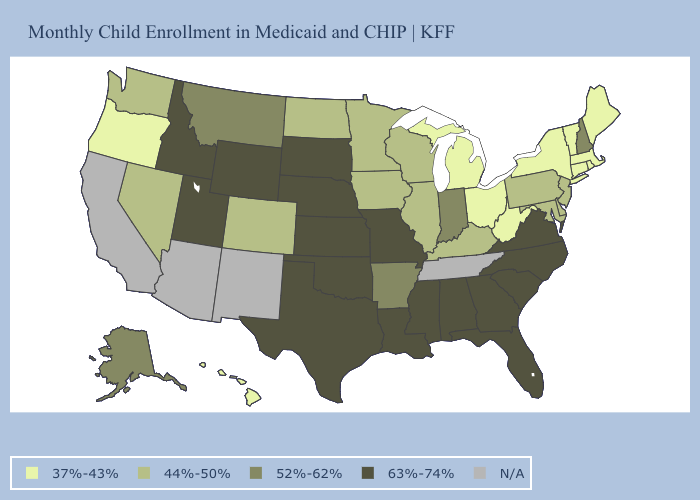What is the lowest value in states that border Montana?
Be succinct. 44%-50%. Among the states that border Kansas , does Nebraska have the lowest value?
Be succinct. No. Which states have the highest value in the USA?
Keep it brief. Alabama, Florida, Georgia, Idaho, Kansas, Louisiana, Mississippi, Missouri, Nebraska, North Carolina, Oklahoma, South Carolina, South Dakota, Texas, Utah, Virginia, Wyoming. What is the value of Utah?
Quick response, please. 63%-74%. Among the states that border Mississippi , which have the highest value?
Write a very short answer. Alabama, Louisiana. Which states have the highest value in the USA?
Quick response, please. Alabama, Florida, Georgia, Idaho, Kansas, Louisiana, Mississippi, Missouri, Nebraska, North Carolina, Oklahoma, South Carolina, South Dakota, Texas, Utah, Virginia, Wyoming. Which states have the highest value in the USA?
Quick response, please. Alabama, Florida, Georgia, Idaho, Kansas, Louisiana, Mississippi, Missouri, Nebraska, North Carolina, Oklahoma, South Carolina, South Dakota, Texas, Utah, Virginia, Wyoming. Among the states that border Wisconsin , does Iowa have the lowest value?
Short answer required. No. Name the states that have a value in the range 44%-50%?
Answer briefly. Colorado, Delaware, Illinois, Iowa, Kentucky, Maryland, Minnesota, Nevada, New Jersey, North Dakota, Pennsylvania, Washington, Wisconsin. Name the states that have a value in the range 44%-50%?
Short answer required. Colorado, Delaware, Illinois, Iowa, Kentucky, Maryland, Minnesota, Nevada, New Jersey, North Dakota, Pennsylvania, Washington, Wisconsin. What is the lowest value in states that border Montana?
Answer briefly. 44%-50%. What is the value of Florida?
Quick response, please. 63%-74%. Which states have the highest value in the USA?
Quick response, please. Alabama, Florida, Georgia, Idaho, Kansas, Louisiana, Mississippi, Missouri, Nebraska, North Carolina, Oklahoma, South Carolina, South Dakota, Texas, Utah, Virginia, Wyoming. What is the value of Illinois?
Concise answer only. 44%-50%. 